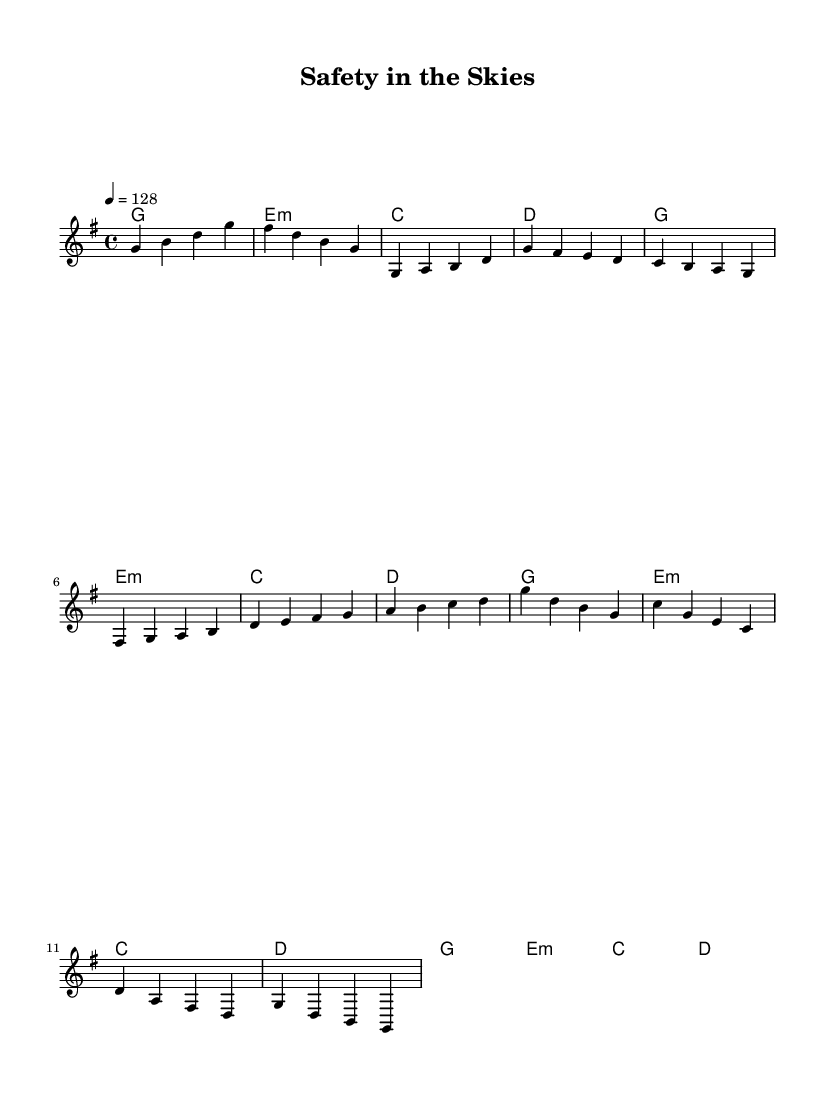what is the key signature of this music? The key signature is G major, which contains one sharp (F#). This can be determined from the first measure where the key is indicated, and the presence of an F# in the melody confirms it.
Answer: G major what is the time signature of this music? The time signature is 4/4, indicated at the beginning of the score. This means there are four beats per measure and the quarter note gets one beat.
Answer: 4/4 what is the tempo marking of this piece? The tempo marking is 128 beats per minute, specified at the beginning of the score with the instruction "4 = 128." This indicates the speed at which the piece should be played.
Answer: 128 how many measures are in the melody? The melody consists of 16 measures if counted by following the segments outlined in the score. Each segment (Intro, Verse, Build-up, and Drop) contributes to the total.
Answer: 16 what is the harmonic progression used in the piece? The harmonic progression follows a repeating pattern of G, E minor, C, and D, as denoted in the chord mode section. This progression is common in house music and creates an uplifting vibe.
Answer: G, E minor, C, D what is the highest note in the melody? The highest note in the melody is D, which appears in the melody section during the build-up part. The notes are analyzed sequentially to determine the highest pitch.
Answer: D how does the structure of this piece reflect typical house music? The structure includes an intro, verse, build-up, and drop, which is characteristic of house music. This mimics the typical arrangement designed to build energy and then release it, suitable for dance settings.
Answer: Intro, verse, build-up, drop 